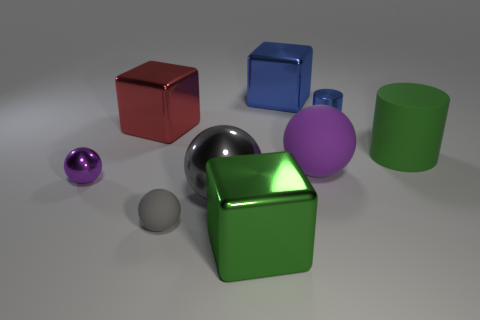What materials are the objects in this image made of? The objects appear to be made of different materials. The red and green objects have a shiny, reflective surface suggesting a metallic or plastic composition, while the purple and smaller green spheres seem to have a matte finish, possibly made of rubber or a non-reflective plastic material. 